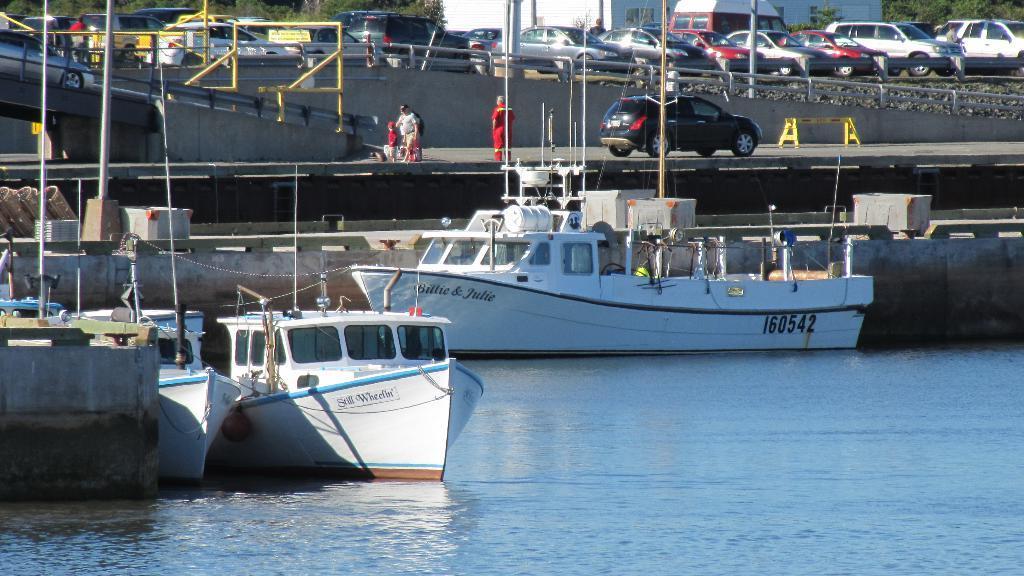Could you give a brief overview of what you see in this image? In this image on the water body there are many boats. On the road a car is moving. There are few people here. here there are many cars moving on the road. Few cars are parked over here. In the background there is building, trees. 